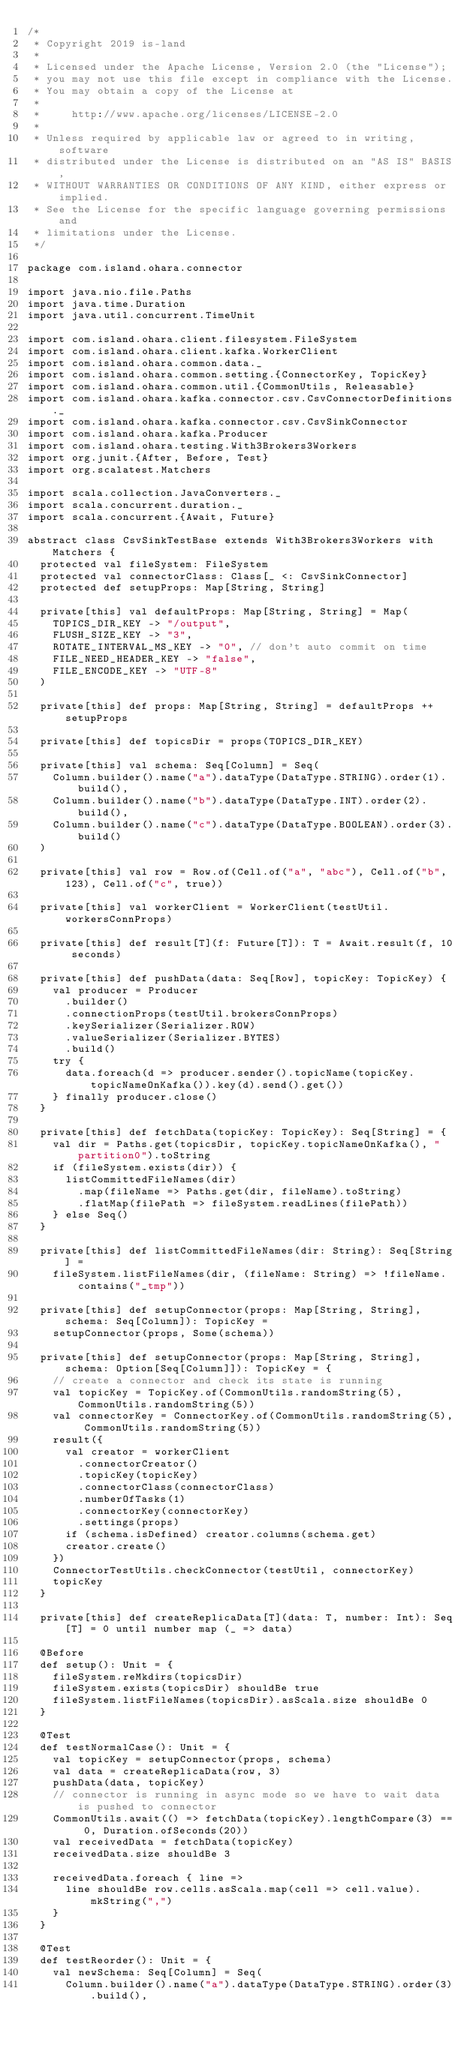Convert code to text. <code><loc_0><loc_0><loc_500><loc_500><_Scala_>/*
 * Copyright 2019 is-land
 *
 * Licensed under the Apache License, Version 2.0 (the "License");
 * you may not use this file except in compliance with the License.
 * You may obtain a copy of the License at
 *
 *     http://www.apache.org/licenses/LICENSE-2.0
 *
 * Unless required by applicable law or agreed to in writing, software
 * distributed under the License is distributed on an "AS IS" BASIS,
 * WITHOUT WARRANTIES OR CONDITIONS OF ANY KIND, either express or implied.
 * See the License for the specific language governing permissions and
 * limitations under the License.
 */

package com.island.ohara.connector

import java.nio.file.Paths
import java.time.Duration
import java.util.concurrent.TimeUnit

import com.island.ohara.client.filesystem.FileSystem
import com.island.ohara.client.kafka.WorkerClient
import com.island.ohara.common.data._
import com.island.ohara.common.setting.{ConnectorKey, TopicKey}
import com.island.ohara.common.util.{CommonUtils, Releasable}
import com.island.ohara.kafka.connector.csv.CsvConnectorDefinitions._
import com.island.ohara.kafka.connector.csv.CsvSinkConnector
import com.island.ohara.kafka.Producer
import com.island.ohara.testing.With3Brokers3Workers
import org.junit.{After, Before, Test}
import org.scalatest.Matchers

import scala.collection.JavaConverters._
import scala.concurrent.duration._
import scala.concurrent.{Await, Future}

abstract class CsvSinkTestBase extends With3Brokers3Workers with Matchers {
  protected val fileSystem: FileSystem
  protected val connectorClass: Class[_ <: CsvSinkConnector]
  protected def setupProps: Map[String, String]

  private[this] val defaultProps: Map[String, String] = Map(
    TOPICS_DIR_KEY -> "/output",
    FLUSH_SIZE_KEY -> "3",
    ROTATE_INTERVAL_MS_KEY -> "0", // don't auto commit on time
    FILE_NEED_HEADER_KEY -> "false",
    FILE_ENCODE_KEY -> "UTF-8"
  )

  private[this] def props: Map[String, String] = defaultProps ++ setupProps

  private[this] def topicsDir = props(TOPICS_DIR_KEY)

  private[this] val schema: Seq[Column] = Seq(
    Column.builder().name("a").dataType(DataType.STRING).order(1).build(),
    Column.builder().name("b").dataType(DataType.INT).order(2).build(),
    Column.builder().name("c").dataType(DataType.BOOLEAN).order(3).build()
  )

  private[this] val row = Row.of(Cell.of("a", "abc"), Cell.of("b", 123), Cell.of("c", true))

  private[this] val workerClient = WorkerClient(testUtil.workersConnProps)

  private[this] def result[T](f: Future[T]): T = Await.result(f, 10 seconds)

  private[this] def pushData(data: Seq[Row], topicKey: TopicKey) {
    val producer = Producer
      .builder()
      .connectionProps(testUtil.brokersConnProps)
      .keySerializer(Serializer.ROW)
      .valueSerializer(Serializer.BYTES)
      .build()
    try {
      data.foreach(d => producer.sender().topicName(topicKey.topicNameOnKafka()).key(d).send().get())
    } finally producer.close()
  }

  private[this] def fetchData(topicKey: TopicKey): Seq[String] = {
    val dir = Paths.get(topicsDir, topicKey.topicNameOnKafka(), "partition0").toString
    if (fileSystem.exists(dir)) {
      listCommittedFileNames(dir)
        .map(fileName => Paths.get(dir, fileName).toString)
        .flatMap(filePath => fileSystem.readLines(filePath))
    } else Seq()
  }

  private[this] def listCommittedFileNames(dir: String): Seq[String] =
    fileSystem.listFileNames(dir, (fileName: String) => !fileName.contains("_tmp"))

  private[this] def setupConnector(props: Map[String, String], schema: Seq[Column]): TopicKey =
    setupConnector(props, Some(schema))

  private[this] def setupConnector(props: Map[String, String], schema: Option[Seq[Column]]): TopicKey = {
    // create a connector and check its state is running
    val topicKey = TopicKey.of(CommonUtils.randomString(5), CommonUtils.randomString(5))
    val connectorKey = ConnectorKey.of(CommonUtils.randomString(5), CommonUtils.randomString(5))
    result({
      val creator = workerClient
        .connectorCreator()
        .topicKey(topicKey)
        .connectorClass(connectorClass)
        .numberOfTasks(1)
        .connectorKey(connectorKey)
        .settings(props)
      if (schema.isDefined) creator.columns(schema.get)
      creator.create()
    })
    ConnectorTestUtils.checkConnector(testUtil, connectorKey)
    topicKey
  }

  private[this] def createReplicaData[T](data: T, number: Int): Seq[T] = 0 until number map (_ => data)

  @Before
  def setup(): Unit = {
    fileSystem.reMkdirs(topicsDir)
    fileSystem.exists(topicsDir) shouldBe true
    fileSystem.listFileNames(topicsDir).asScala.size shouldBe 0
  }

  @Test
  def testNormalCase(): Unit = {
    val topicKey = setupConnector(props, schema)
    val data = createReplicaData(row, 3)
    pushData(data, topicKey)
    // connector is running in async mode so we have to wait data is pushed to connector
    CommonUtils.await(() => fetchData(topicKey).lengthCompare(3) == 0, Duration.ofSeconds(20))
    val receivedData = fetchData(topicKey)
    receivedData.size shouldBe 3

    receivedData.foreach { line =>
      line shouldBe row.cells.asScala.map(cell => cell.value).mkString(",")
    }
  }

  @Test
  def testReorder(): Unit = {
    val newSchema: Seq[Column] = Seq(
      Column.builder().name("a").dataType(DataType.STRING).order(3).build(),</code> 